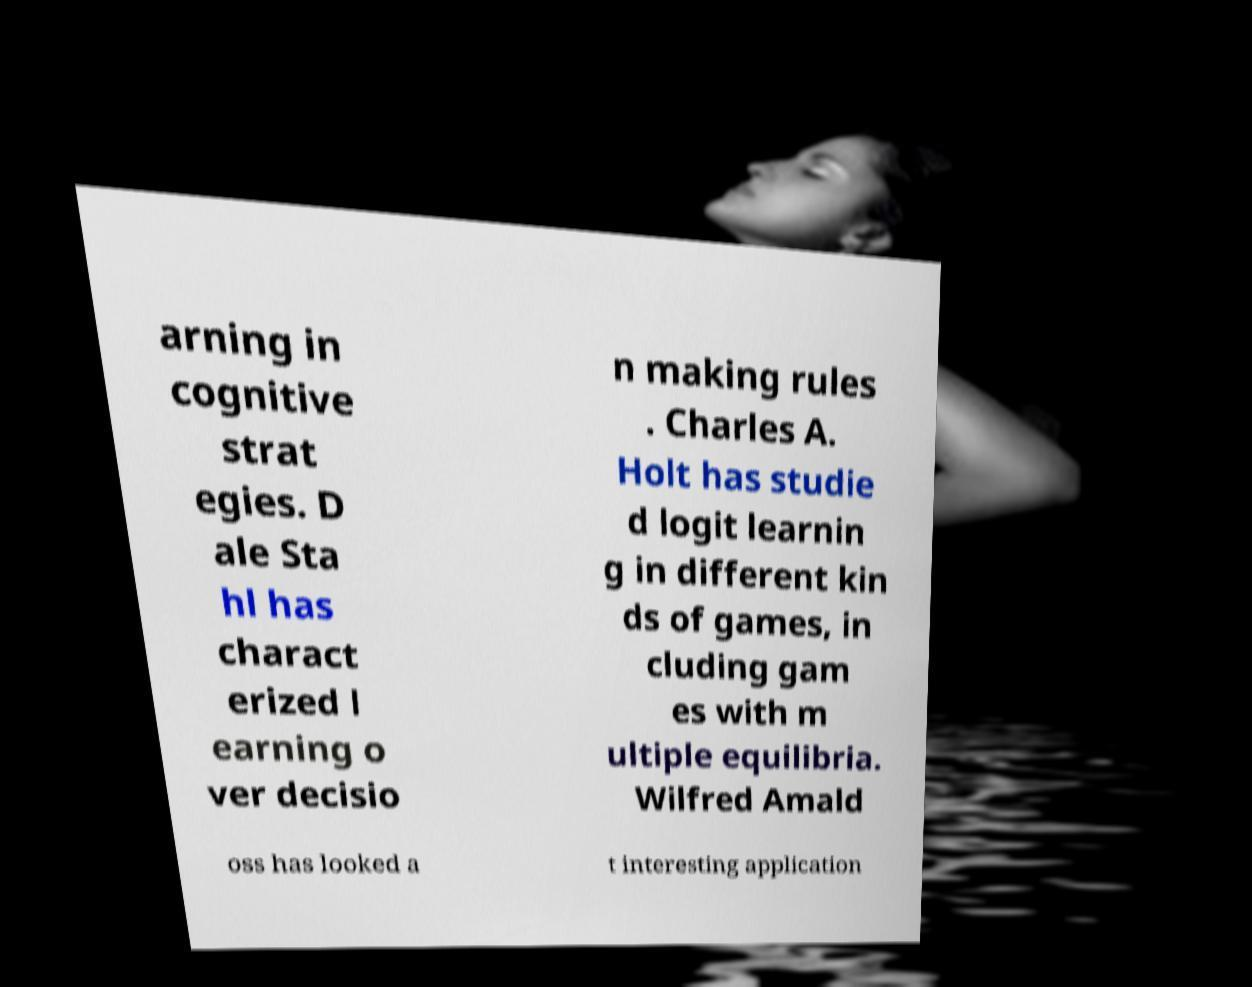Please read and relay the text visible in this image. What does it say? arning in cognitive strat egies. D ale Sta hl has charact erized l earning o ver decisio n making rules . Charles A. Holt has studie d logit learnin g in different kin ds of games, in cluding gam es with m ultiple equilibria. Wilfred Amald oss has looked a t interesting application 